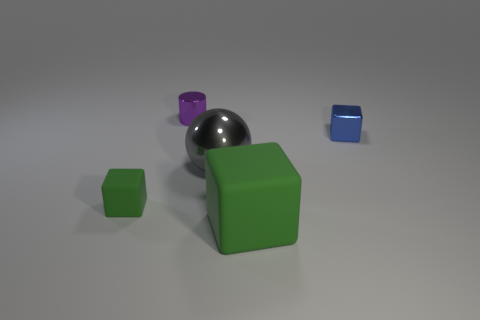Is the number of big matte blocks on the left side of the purple metal object greater than the number of tiny cubes that are on the right side of the tiny blue block?
Keep it short and to the point. No. There is a thing that is the same size as the gray shiny sphere; what is it made of?
Your response must be concise. Rubber. What number of other objects are the same material as the small cylinder?
Keep it short and to the point. 2. Is the shape of the small metallic object that is to the left of the shiny ball the same as the tiny thing that is in front of the big shiny object?
Give a very brief answer. No. What number of other things are the same color as the metallic ball?
Give a very brief answer. 0. Do the green block on the right side of the purple cylinder and the tiny thing that is on the right side of the gray metallic thing have the same material?
Provide a succinct answer. No. Are there the same number of small cylinders that are in front of the big green object and large gray balls on the left side of the large ball?
Provide a short and direct response. Yes. There is a block to the left of the small metal cylinder; what is its material?
Offer a very short reply. Rubber. Are there any other things that are the same size as the metal ball?
Provide a succinct answer. Yes. Are there fewer small blue metal objects than cubes?
Your answer should be compact. Yes. 